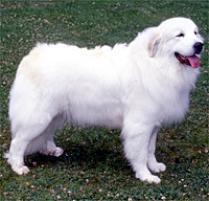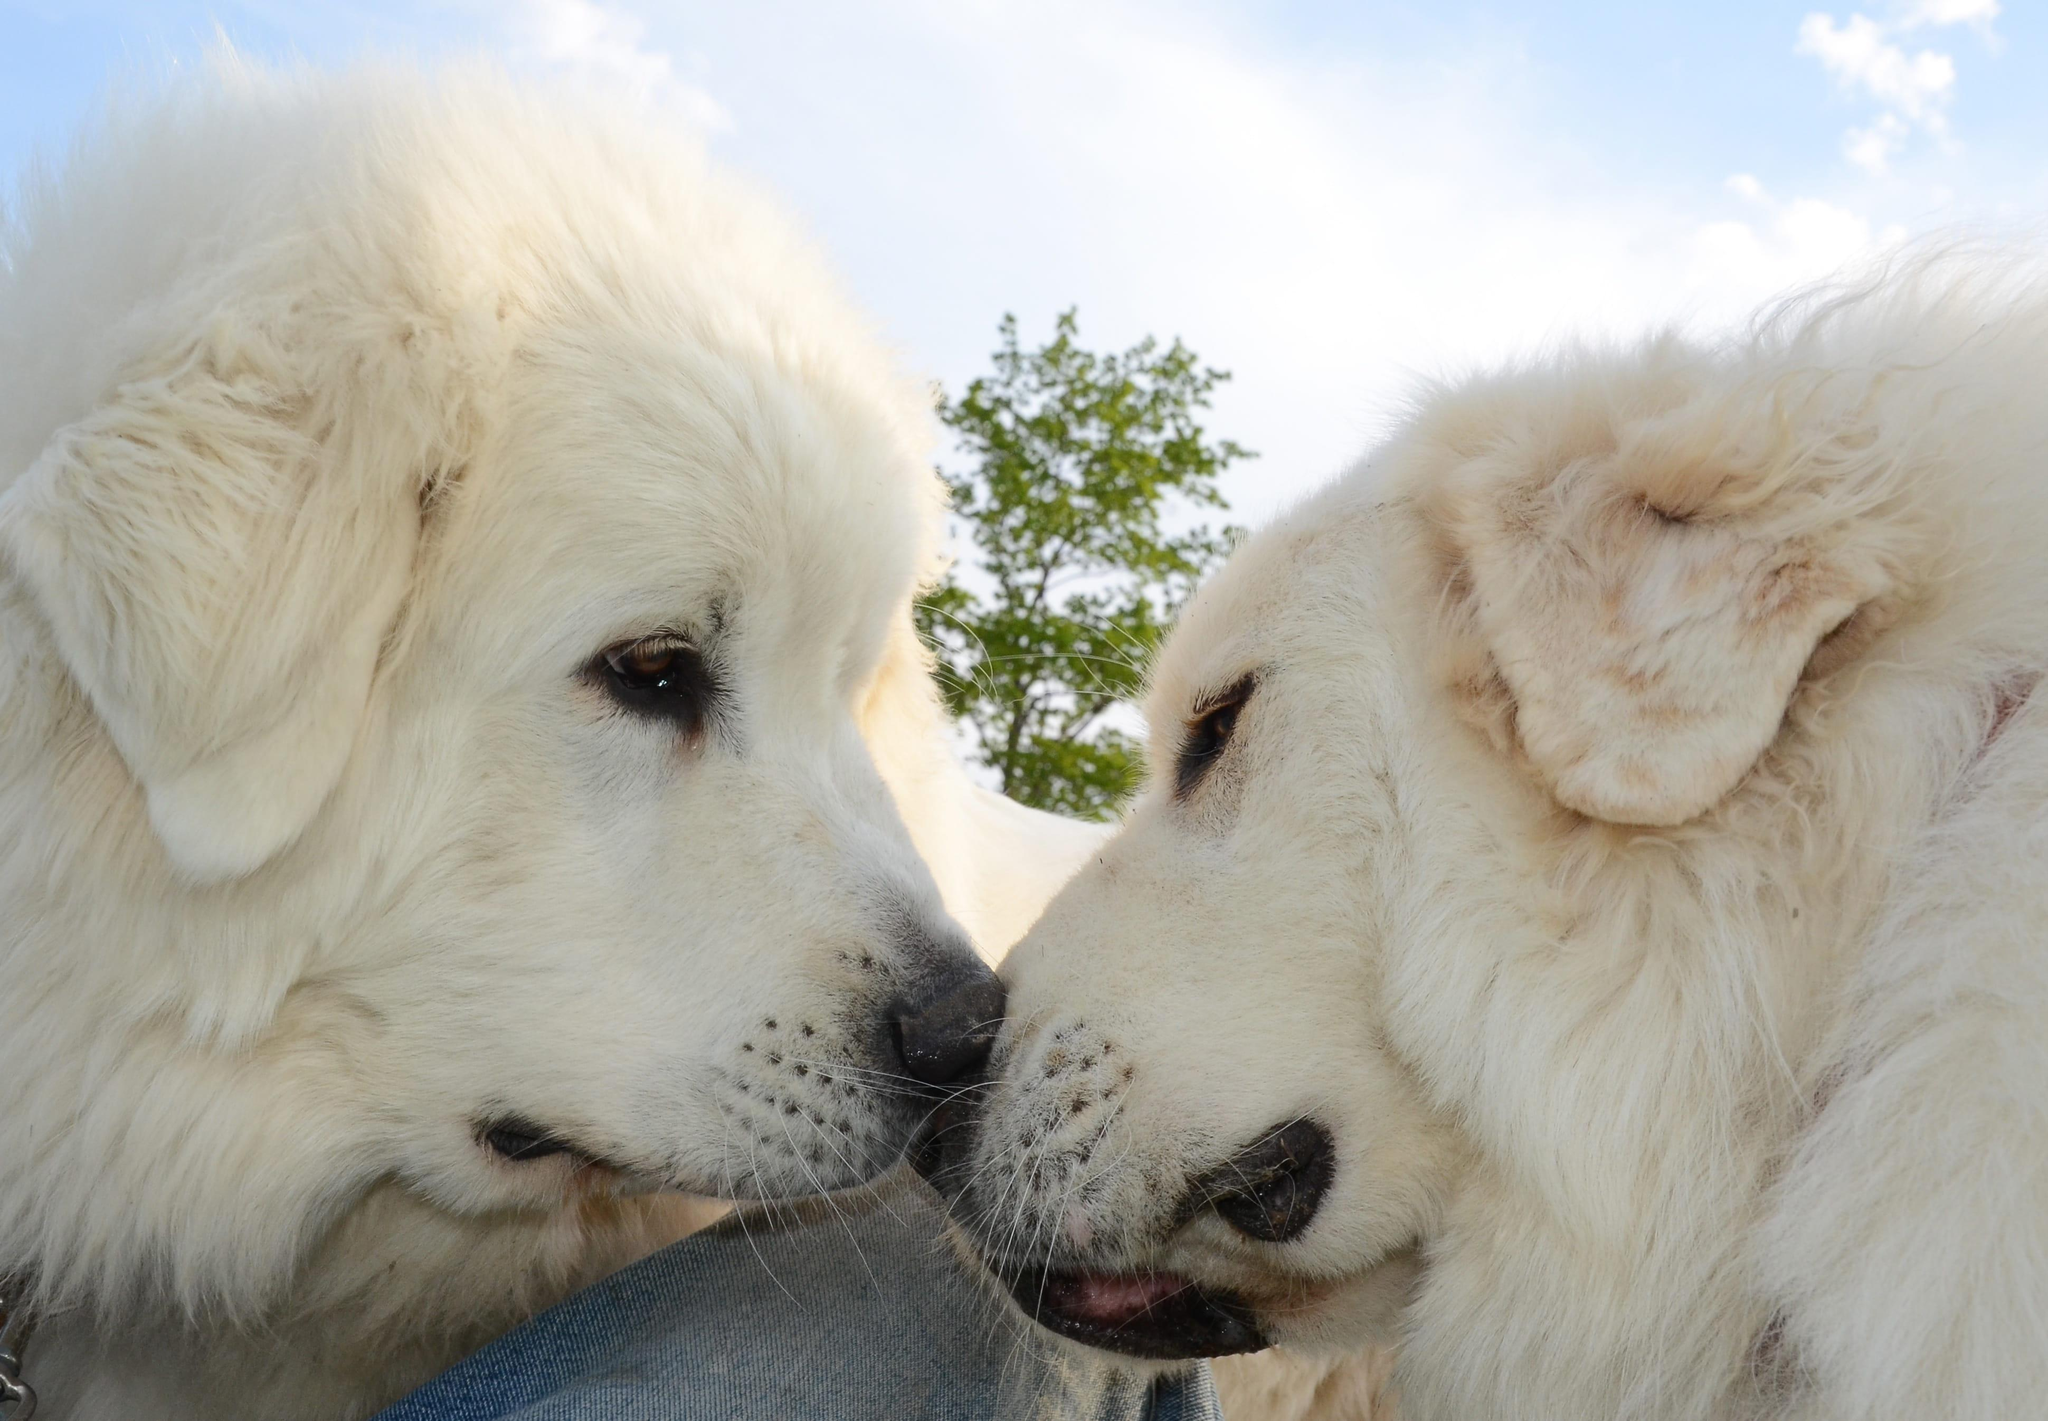The first image is the image on the left, the second image is the image on the right. Considering the images on both sides, is "The right image has two dogs near each other." valid? Answer yes or no. Yes. 